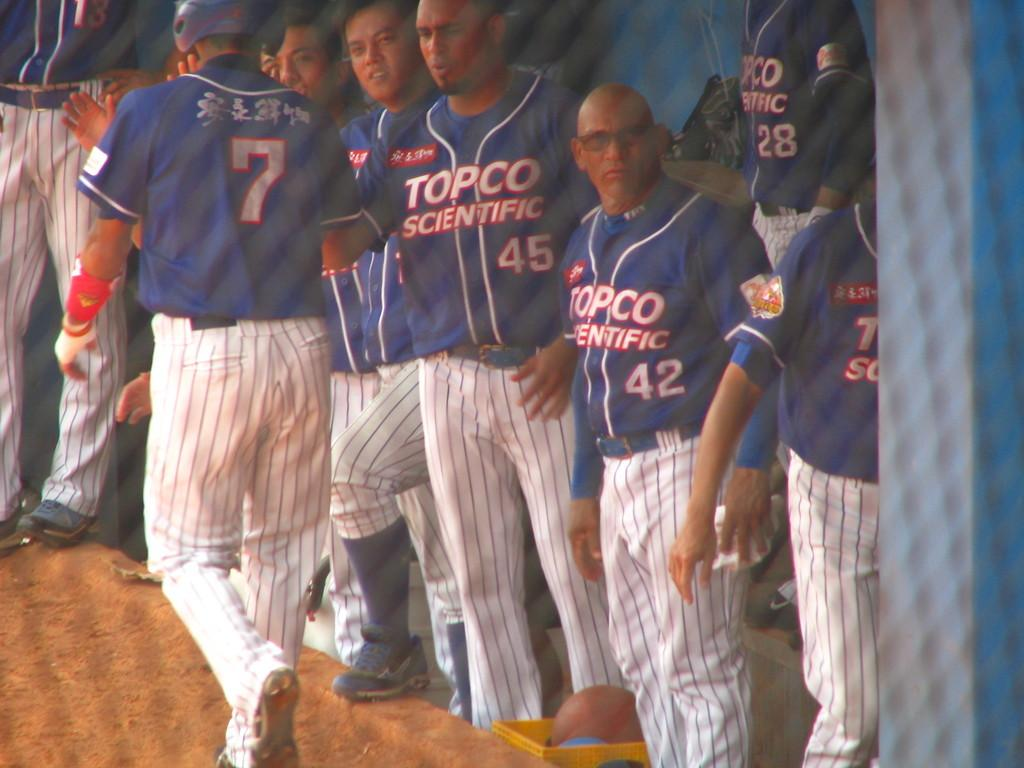Provide a one-sentence caption for the provided image. A group of baseball player in TOPCO SCIENTIFIC uniform. 